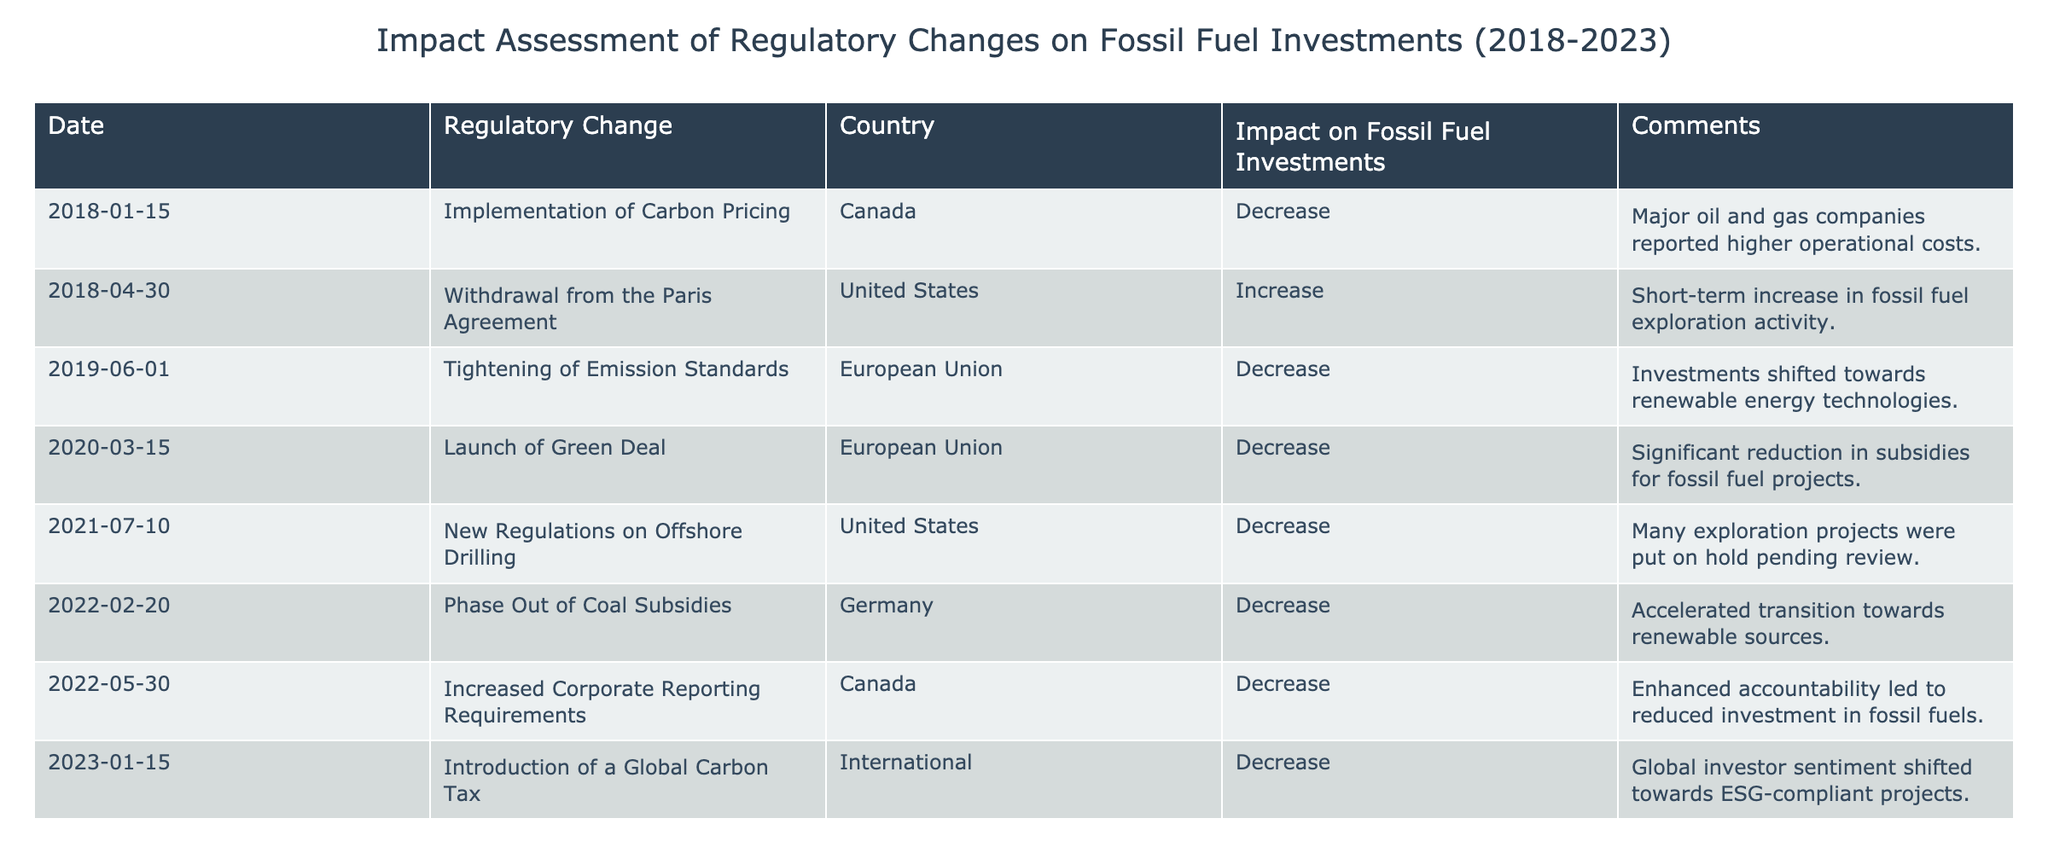Which regulatory change occurred in the United States in April 2018? The table indicates that the withdrawal from the Paris Agreement took place in the United States on April 30, 2018.
Answer: Withdrawal from the Paris Agreement What was the impact on fossil fuel investments due to the introduction of a global carbon tax in January 2023? According to the table, the introduction of a global carbon tax had a decrease in fossil fuel investments as stated in the impact column.
Answer: Decrease How many regulatory changes resulted in a decrease in fossil fuel investments? To find this, count the occurrences of "Decrease" in the impact column. There are six regulatory changes that resulted in a decrease in fossil fuel investments from the provided data.
Answer: 6 In which country was there an increase in fossil fuel investments due to a regulatory change, and what was the specific change? The only instance where an increase is noted is in the United States due to the withdrawal from the Paris Agreement.
Answer: United States, Withdrawal from the Paris Agreement What was the total number of regulatory changes recorded from 2018 to 2023? The table lists a total of eight regulatory changes, which can be counted from the Date column.
Answer: 8 Did the Phase Out of Coal Subsidies in Germany result in an increase in fossil fuel investments? The table clearly states that the impact of the Phase Out of Coal Subsidies in Germany is a decrease, thus the answer is no.
Answer: No How did the tightening of emission standards in the European Union affect investments compared to the introduction of corporate reporting requirements in Canada? The tightening of emission standards resulted in a decrease, and the introduction of corporate reporting requirements also resulted in a decrease. Thus, both had the same impact.
Answer: Both resulted in a decrease Which regulatory change had the earliest date among those listed? The analysis shows that the implementation of carbon pricing on January 15, 2018, is the earliest date among the changes listed.
Answer: Implementation of Carbon Pricing 